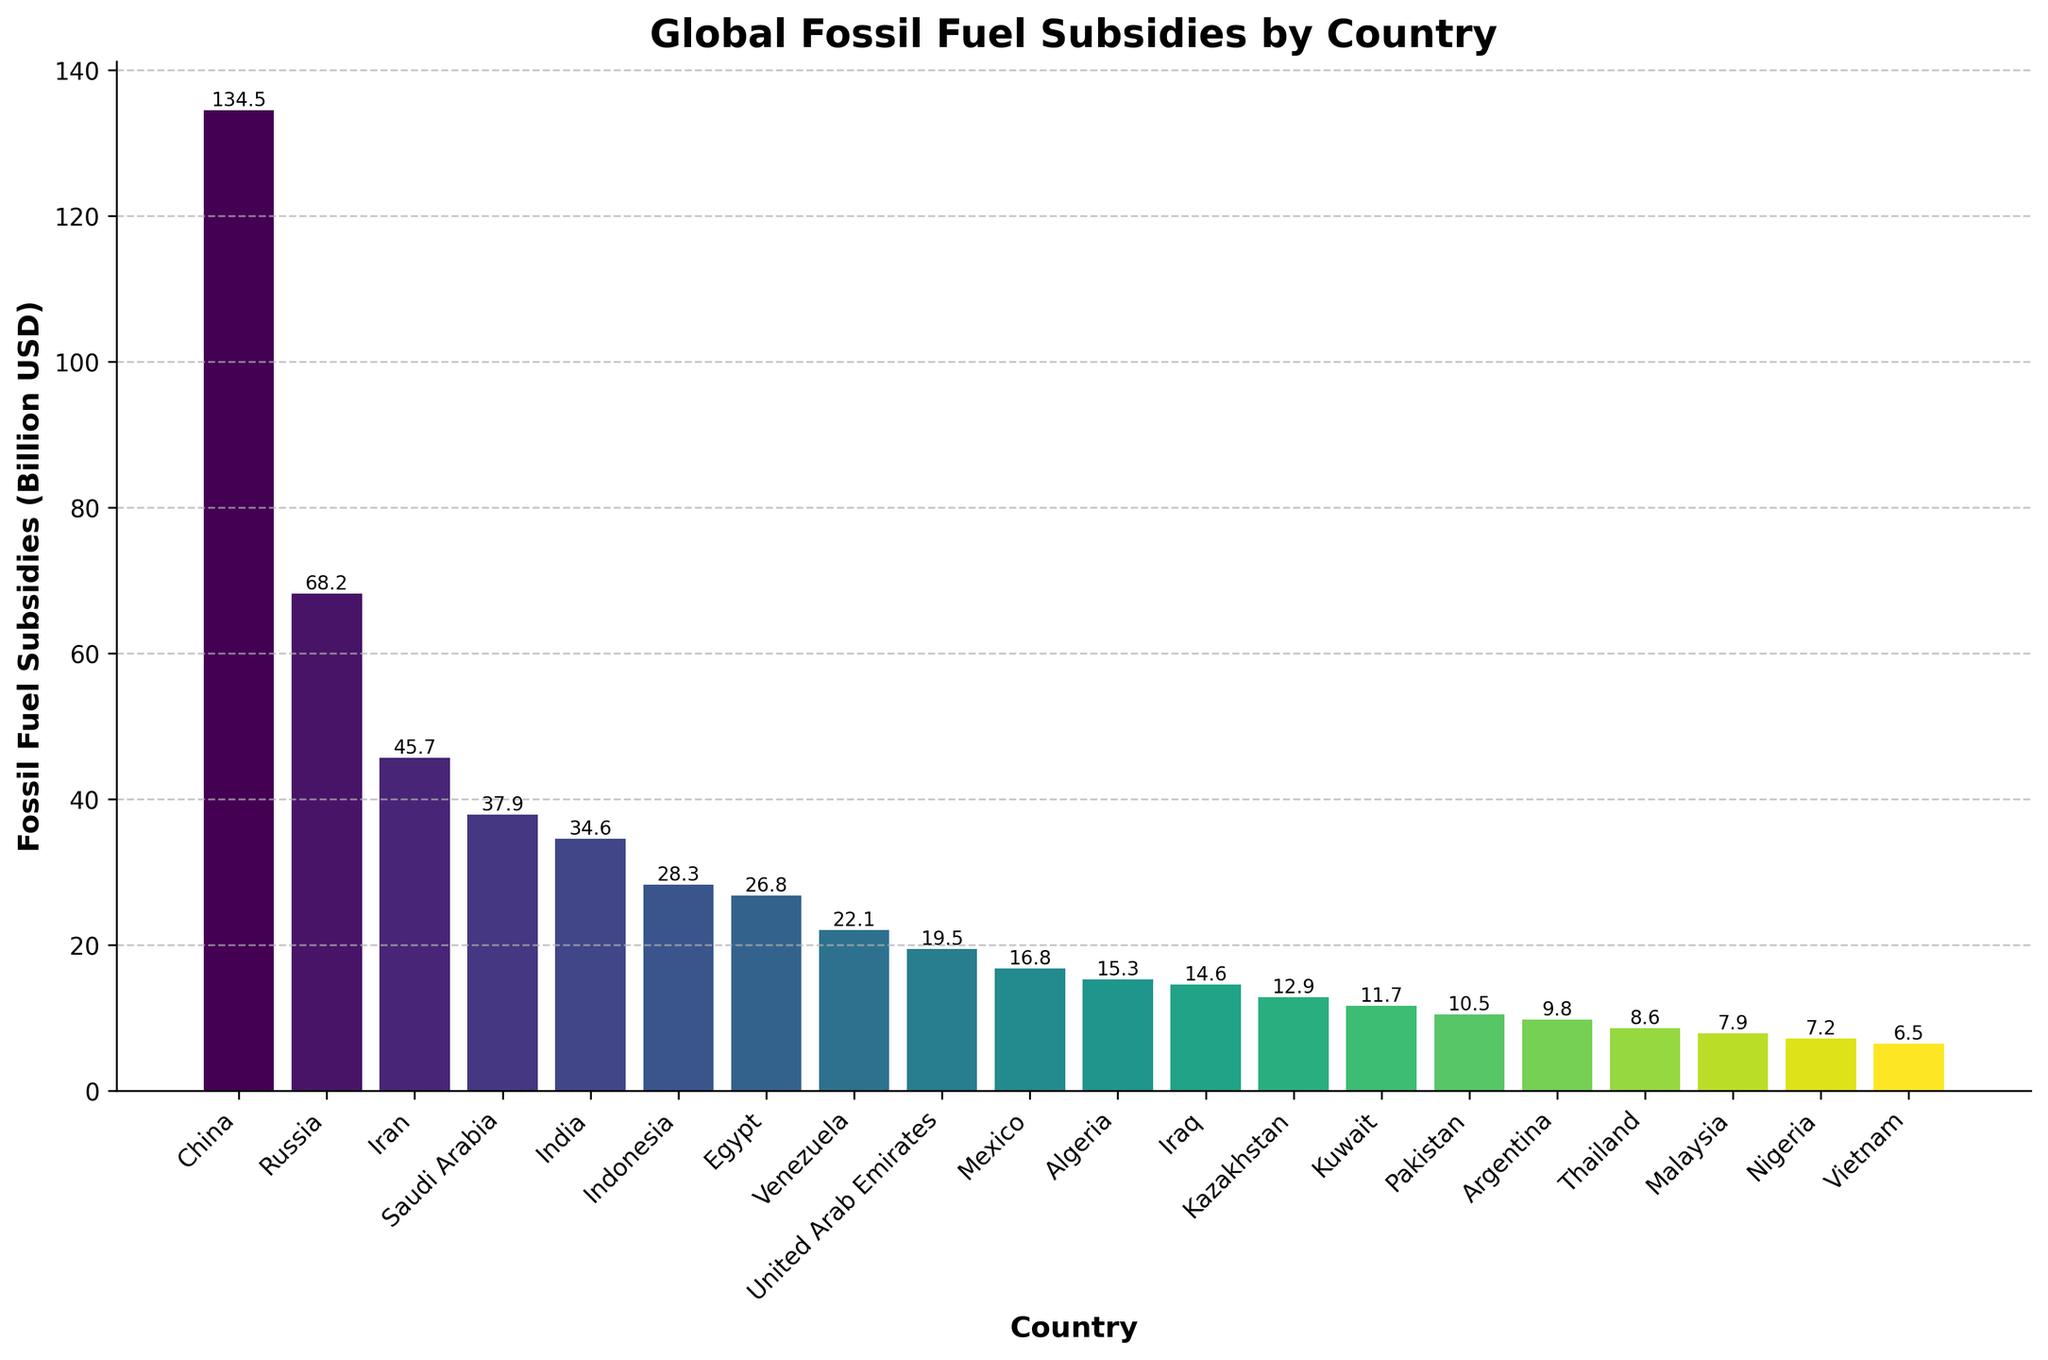What is the range of fossil fuel subsidies in the provided data? The range is calculated by finding the difference between the highest and the lowest subsidy values. The highest subsidy is for China at $134.5 billion, and the lowest is for Vietnam at $6.5 billion. Thus, the range is $134.5 billion - $6.5 billion = $128 billion.
Answer: $128 billion Which country provides more fossil fuel subsidies, India or Indonesia? To compare, we look at the bar heights for India and Indonesia. India's subsidy is $34.6 billion, while Indonesia's is $28.3 billion. Since $34.6 billion is greater than $28.3 billion, India provides more subsidies.
Answer: India What is the combined fossil fuel subsidy of Saudi Arabia and Venezuela? Add the subsidies of Saudi Arabia ($37.9 billion) and Venezuela ($22.1 billion). The combined subsidy is $37.9 billion + $22.1 billion = $60 billion.
Answer: $60 billion Which country has the highest fossil fuel subsidy and what is the amount? The highest bar represents China, with a subsidy of $134.5 billion.
Answer: China, $134.5 billion How many countries have subsidies greater than $20 billion? Count the number of bars that exceed the $20 billion mark. The countries are China, Russia, Iran, Saudi Arabia, India, Indonesia, Egypt, and Venezuela. This makes a total of 8 countries.
Answer: 8 Arrange the top five countries by fossil fuel subsidies in descending order. First identify the top five countries: 1) China ($134.5 billion), 2) Russia ($68.2 billion), 3) Iran ($45.7 billion), 4) Saudi Arabia ($37.9 billion), 5) India ($34.6 billion). List them in descending order as China, Russia, Iran, Saudi Arabia, and India.
Answer: China, Russia, Iran, Saudi Arabia, India Calculate the average fossil fuel subsidy for the countries listed. Sum the subsidies: 134.5 + 68.2 + 45.7 + 37.9 + 34.6 + 28.3 + 26.8 + 22.1 + 19.5 + 16.8 + 15.3 + 14.6 + 12.9 + 11.7 + 10.5 + 9.8 + 8.6 + 7.9 + 7.2 + 6.5 = 538.4 billion USD. There are 20 countries, so the average is 538.4 / 20 = 26.92 billion USD.
Answer: 26.92 billion USD Which country has the lowest fossil fuel subsidy, and what is the amount? The shortest bar in the figure represents Vietnam, with a subsidy of $6.5 billion.
Answer: Vietnam, $6.5 billion What is the difference in fossil fuel subsidies between Egypt and Nigeria? Subtract Nigeria's subsidy ($7.2 billion) from Egypt's subsidy ($26.8 billion). The difference is $26.8 billion - $7.2 billion = $19.6 billion.
Answer: $19.6 billion Identify the country with approximately half the fossil fuel subsidy of Russia. Russia's subsidy is $68.2 billion. Half of this amount is 68.2 / 2 = $34.1 billion. The country closest to this value is India with $34.6 billion.
Answer: India 